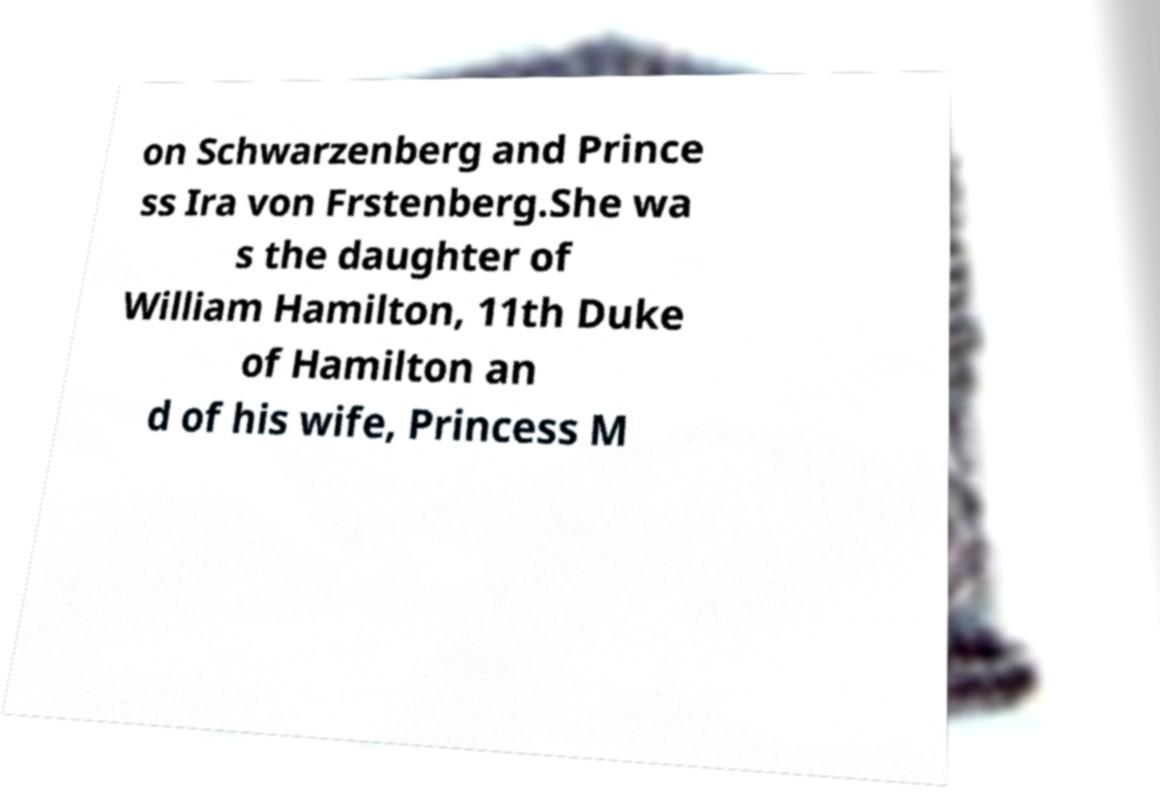I need the written content from this picture converted into text. Can you do that? on Schwarzenberg and Prince ss Ira von Frstenberg.She wa s the daughter of William Hamilton, 11th Duke of Hamilton an d of his wife, Princess M 